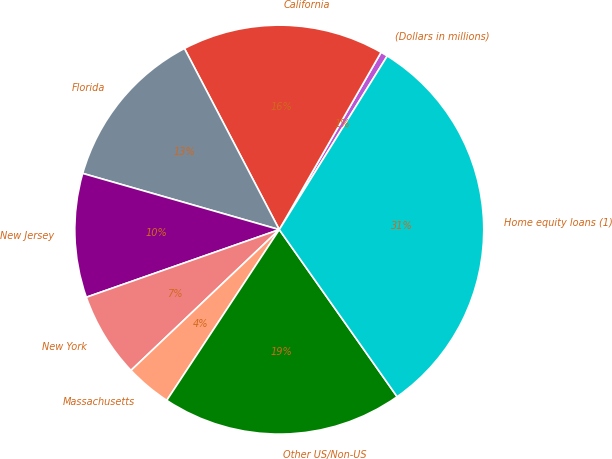Convert chart. <chart><loc_0><loc_0><loc_500><loc_500><pie_chart><fcel>(Dollars in millions)<fcel>California<fcel>Florida<fcel>New Jersey<fcel>New York<fcel>Massachusetts<fcel>Other US/Non-US<fcel>Home equity loans (1)<nl><fcel>0.56%<fcel>15.97%<fcel>12.89%<fcel>9.8%<fcel>6.72%<fcel>3.64%<fcel>19.05%<fcel>31.37%<nl></chart> 